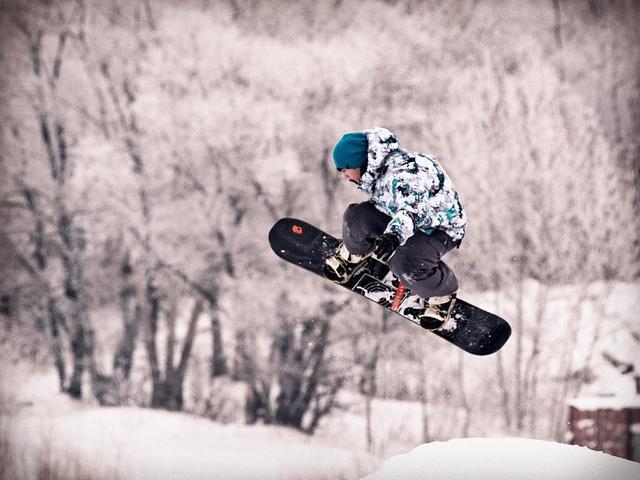How many oxygen tubes is the man in the bed wearing?
Give a very brief answer. 0. 